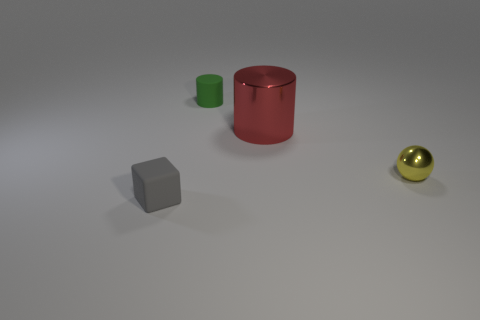Add 4 red objects. How many objects exist? 8 Subtract all balls. How many objects are left? 3 Add 3 red cylinders. How many red cylinders exist? 4 Subtract 0 cyan cylinders. How many objects are left? 4 Subtract all red shiny cylinders. Subtract all green rubber objects. How many objects are left? 2 Add 1 yellow shiny spheres. How many yellow shiny spheres are left? 2 